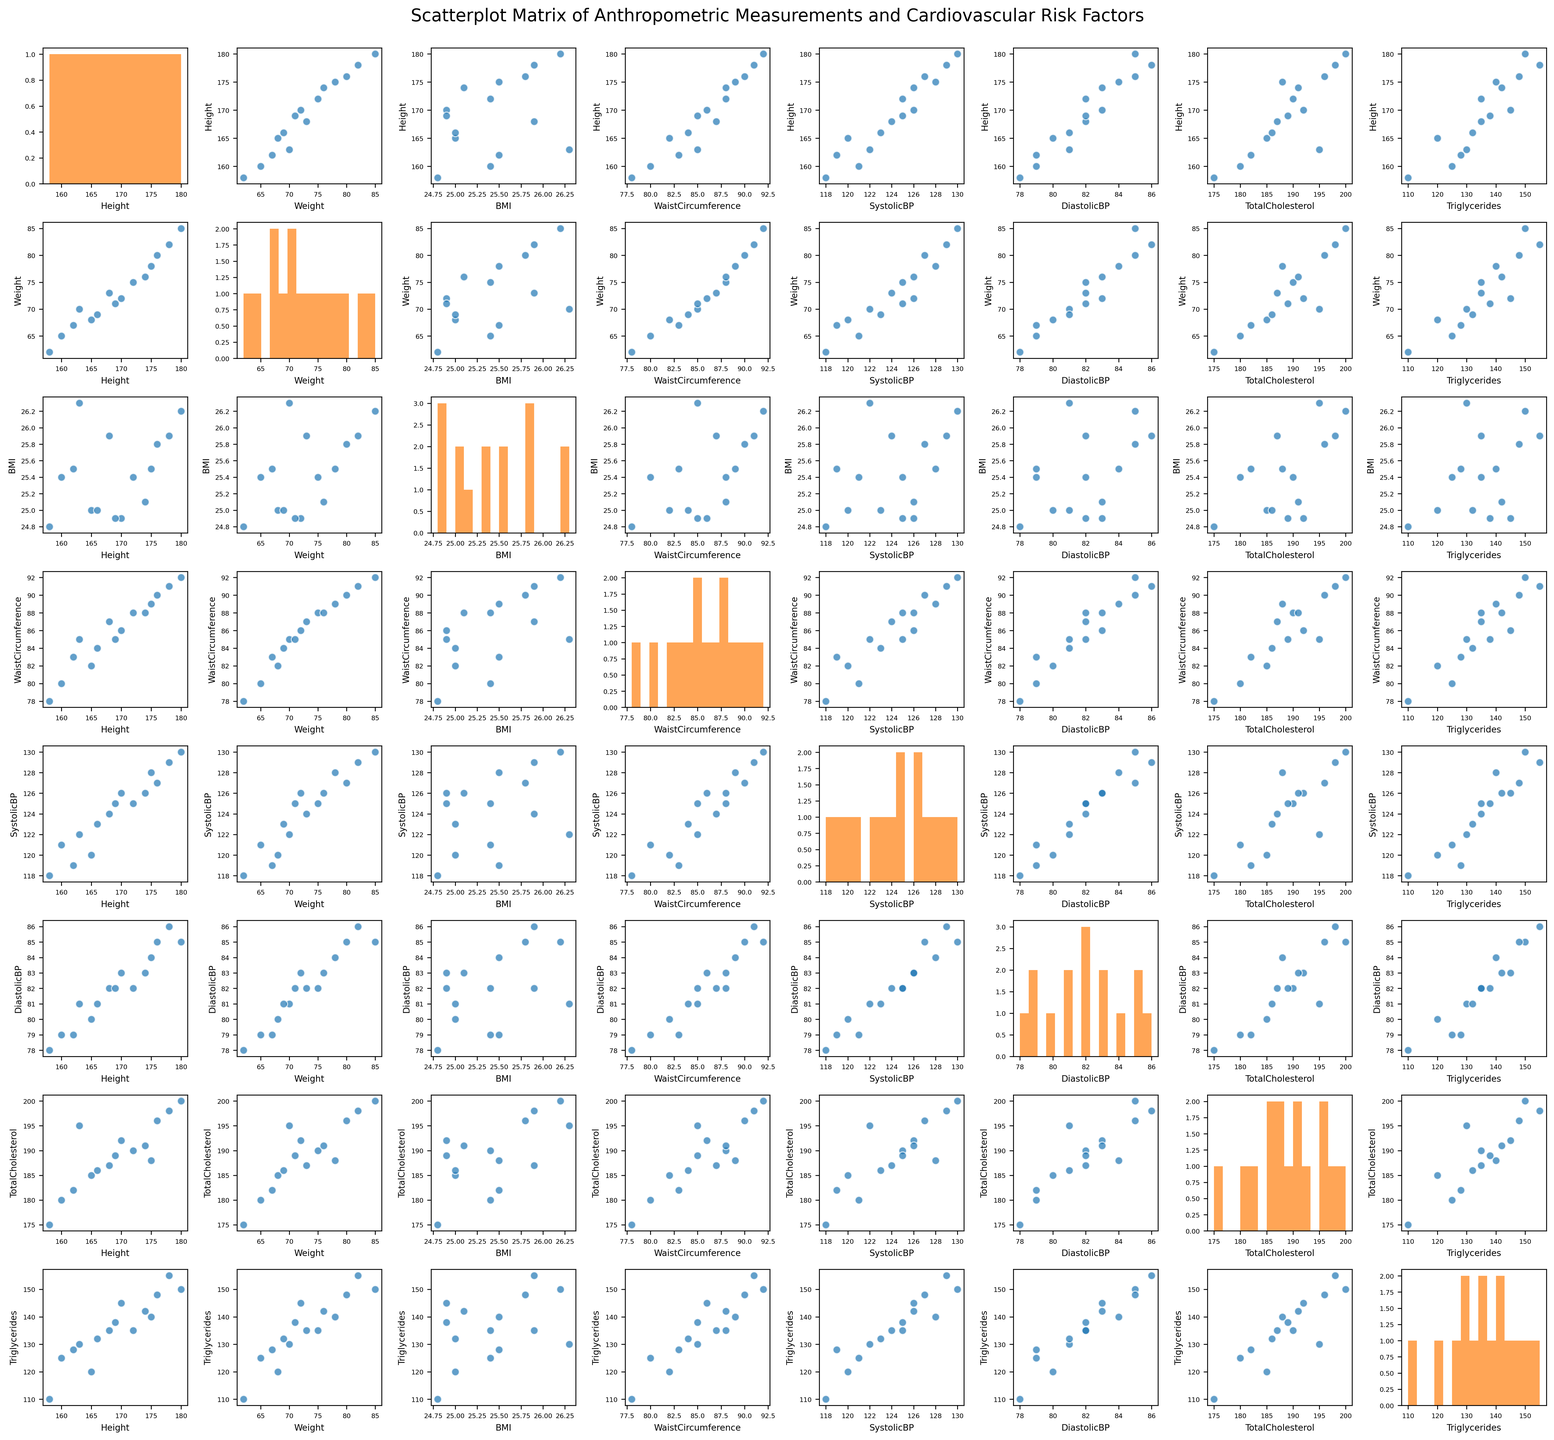What is the title of the figure? The title is usually positioned at the top of the figure in a larger and bold font. In this case, the title is given as 'Scatterplot Matrix of Anthropometric Measurements and Cardiovascular Risk Factors'.
Answer: Scatterplot Matrix of Anthropometric Measurements and Cardiovascular Risk Factors What variables are plotted on the axes of the matrix? The variables are found on the x and y axes of the plots within the matrix. Scanning through the axes reveals the following variables: Height, Weight, BMI, Waist Circumference, Systolic Blood Pressure, Diastolic Blood Pressure, Total Cholesterol, and Triglycerides.
Answer: Height, Weight, BMI, Waist Circumference, Systolic Blood Pressure, Diastolic Blood Pressure, Total Cholesterol, Triglycerides Which variable shows the widest range in its histogram? To determine this, we should look for the variable with the histogram that shows the most spread-out bars. This can be visually assessed by examining the width of the values on the x-axis of the histograms in each diagonal cell.
Answer: Height How many variables are included in the scatterplot matrix? Counting both the rows and the columns of the scatterplot matrix will give the total number of variables displayed. Each row and column corresponds to a different variable.
Answer: 8 Is there a visible trend between Waist Circumference and Triglycerides? To find this, check the scatterplot where Waist Circumference is on one axis and Triglycerides is on the other axis. Look for any positive or negative trend in the data points.
Answer: Yes, a positive trend Which variables have a more apparent relationship: BMI and Systolic BP or BMI and Diastolic BP? By comparing the scatterplots of BMI versus Systolic BP and BMI versus Diastolic BP, the one with a clearer trend (points forming a more distinct line) indicates a stronger apparent relationship.
Answer: BMI and Systolic BP Which pair of variables appears to have the least correlation? Look for the scatterplot where the data points are most dispersed without forming any distinguishable pattern. This indicates a lower correlation between the pair of variables.
Answer: Height and Total Cholesterol Based on the scatterplot matrix, which variable might have the strongest correlation with Weight? Check the scatterplots where Weight is on one axis and identify which other variable collates most clearly with it, i.e., where the points form a tighter linear pattern.
Answer: BMI What could be inferred from histograms about the distribution of Systolic BP and Diastolic BP? Examine the histograms for Systolic BP and Diastolic BP. Look for clues about their distribution shapes, like whether they appear normal (bell-shaped), skewed, or uniform.
Answer: Systolic BP is skewed right, Diastolic BP is somewhat uniform Which plot indicates a potential outlier in the dataset? An outlier is typically a point far removed from the rest of the data in a scatterplot. Look for any scatterplot that has a point significantly apart from the clustered points.
Answer: Triglycerides vs Waist Circumference 